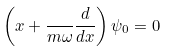<formula> <loc_0><loc_0><loc_500><loc_500>\left ( x + { \frac { } { m \omega } } { \frac { d } { d x } } \right ) \psi _ { 0 } = 0</formula> 